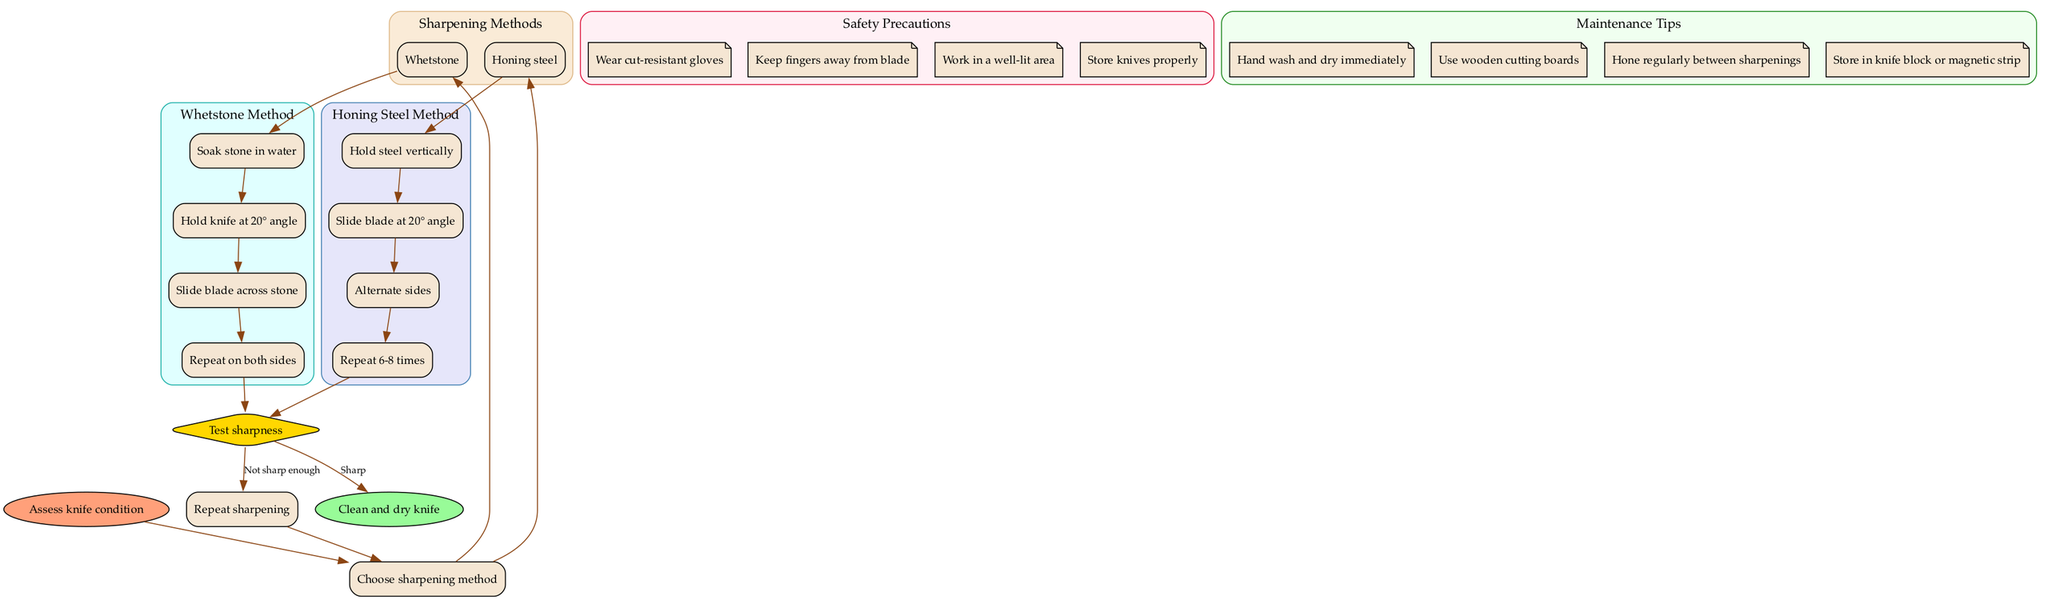What is the first step in the knife sharpening process? The flow chart starts with "Assess knife condition," indicating that this is the initial step in the instruction for sharpening knives.
Answer: Assess knife condition How many sharpening methods are presented in the diagram? The diagram shows two options under "Choose sharpening method": Whetstone and Honing steel, indicating that there are two sharpening methods available.
Answer: 2 What angle should the knife be held at when using a honing steel? The step for using honing steel specifies to "Slide blade at 20° angle," indicating that 20 degrees is the angle for honing.
Answer: 20° What should be done if the knife is "Not sharp enough"? The diagram leads from the "Test sharpness" decision node back to "Repeat sharpening" if the knife is not sharp enough, indicating that the sharpening process should continue.
Answer: Repeat sharpening Which safety precaution is mentioned in the diagram? The diagram contains a section labeled "Safety Precautions," listing items like "Wear cut-resistant gloves," which is one of the precautions to ensure safety during knife sharpening.
Answer: Wear cut-resistant gloves What is the last action to take after sharpening the knife if it is sharp? According to the flow chart, if the knife is deemed "Sharp," the next step is to "Clean and dry knife," indicating that this is the final action after sharpening.
Answer: Clean and dry knife What is a maintenance tip for kitchen knives mentioned in the diagram? One of the maintenance tips listed in the diagram is "Hand wash and dry immediately," which provides guidance on how to maintain the condition of kitchen knives.
Answer: Hand wash and dry immediately What comes after performing the sharpening steps with a whetstone? After completing the last step of using a whetstone, which is "Repeat on both sides," the diagram indicates that the next step is to "Test sharpness."
Answer: Test sharpness 